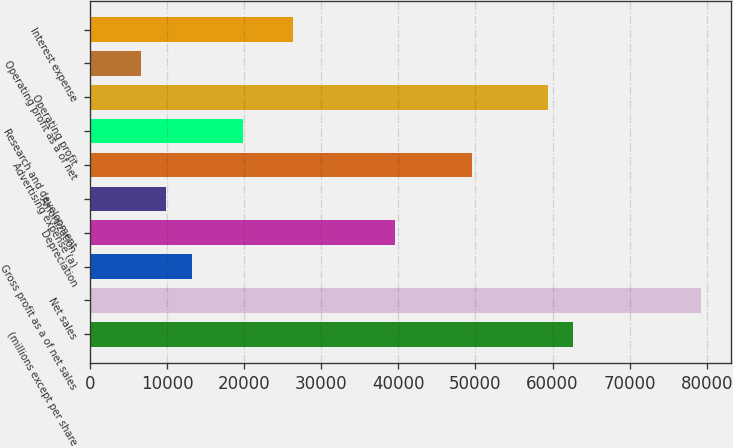Convert chart to OTSL. <chart><loc_0><loc_0><loc_500><loc_500><bar_chart><fcel>(millions except per share<fcel>Net sales<fcel>Gross profit as a of net sales<fcel>Depreciation<fcel>Amortization<fcel>Advertising expense (a)<fcel>Research and development<fcel>Operating profit<fcel>Operating profit as a of net<fcel>Interest expense<nl><fcel>62698.1<fcel>79197.1<fcel>13201.3<fcel>39599.6<fcel>9901.49<fcel>49499<fcel>19800.9<fcel>59398.3<fcel>6601.7<fcel>26400.4<nl></chart> 